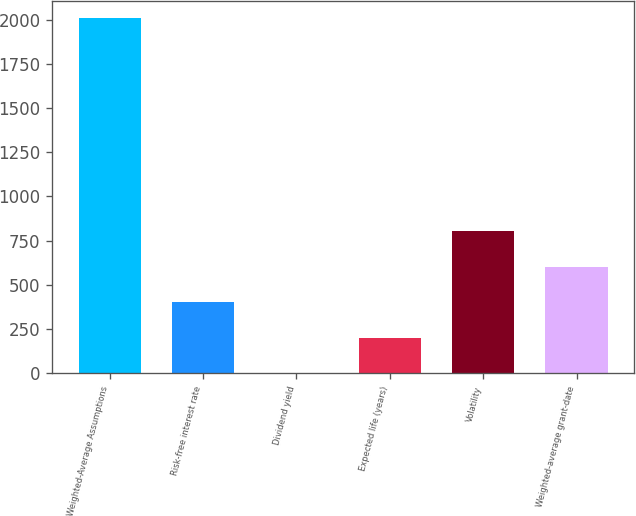Convert chart to OTSL. <chart><loc_0><loc_0><loc_500><loc_500><bar_chart><fcel>Weighted-Average Assumptions<fcel>Risk-free interest rate<fcel>Dividend yield<fcel>Expected life (years)<fcel>Volatility<fcel>Weighted-average grant-date<nl><fcel>2007<fcel>402.52<fcel>1.4<fcel>201.96<fcel>803.64<fcel>603.08<nl></chart> 